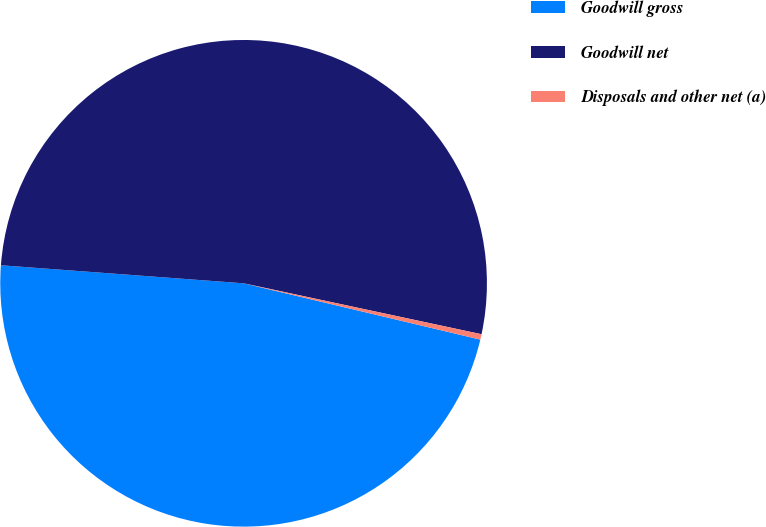Convert chart to OTSL. <chart><loc_0><loc_0><loc_500><loc_500><pie_chart><fcel>Goodwill gross<fcel>Goodwill net<fcel>Disposals and other net (a)<nl><fcel>47.47%<fcel>52.18%<fcel>0.36%<nl></chart> 